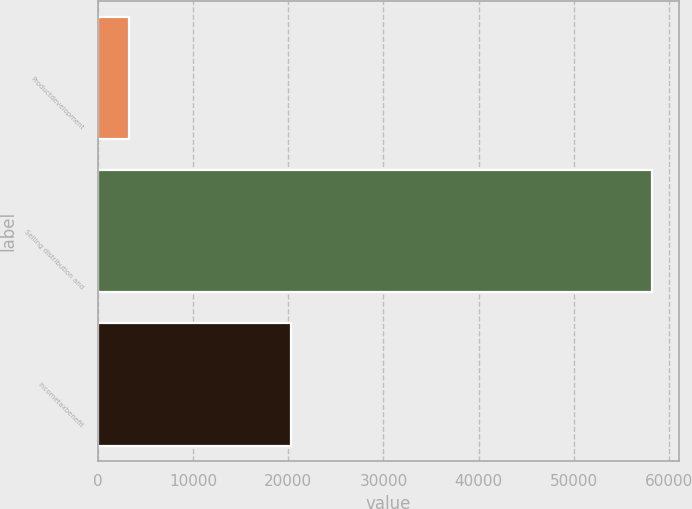Convert chart. <chart><loc_0><loc_0><loc_500><loc_500><bar_chart><fcel>Productdevelopment<fcel>Selling distribution and<fcel>Incometaxbenefit<nl><fcel>3248<fcel>58176<fcel>20298<nl></chart> 